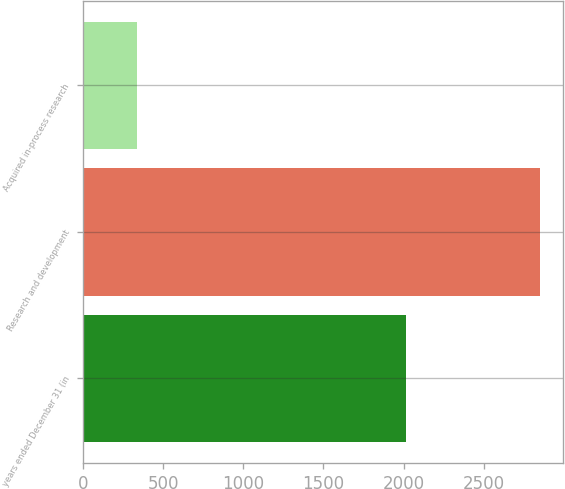<chart> <loc_0><loc_0><loc_500><loc_500><bar_chart><fcel>years ended December 31 (in<fcel>Research and development<fcel>Acquired in-process research<nl><fcel>2013<fcel>2855<fcel>338<nl></chart> 